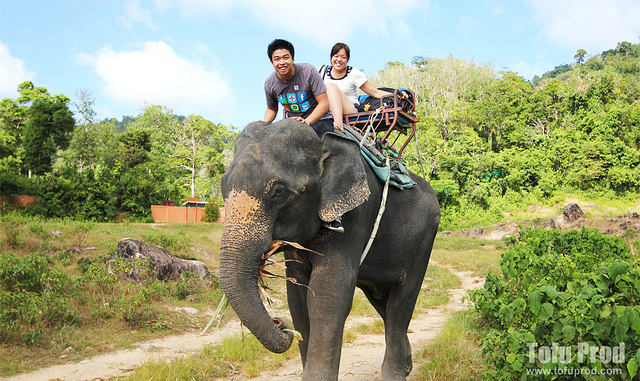<image>Do you think these people are on vacation? I am not sure if these people are on vacation or not. Do you think these people are on vacation? I don't know if these people are on vacation. It can be both yes or no. 